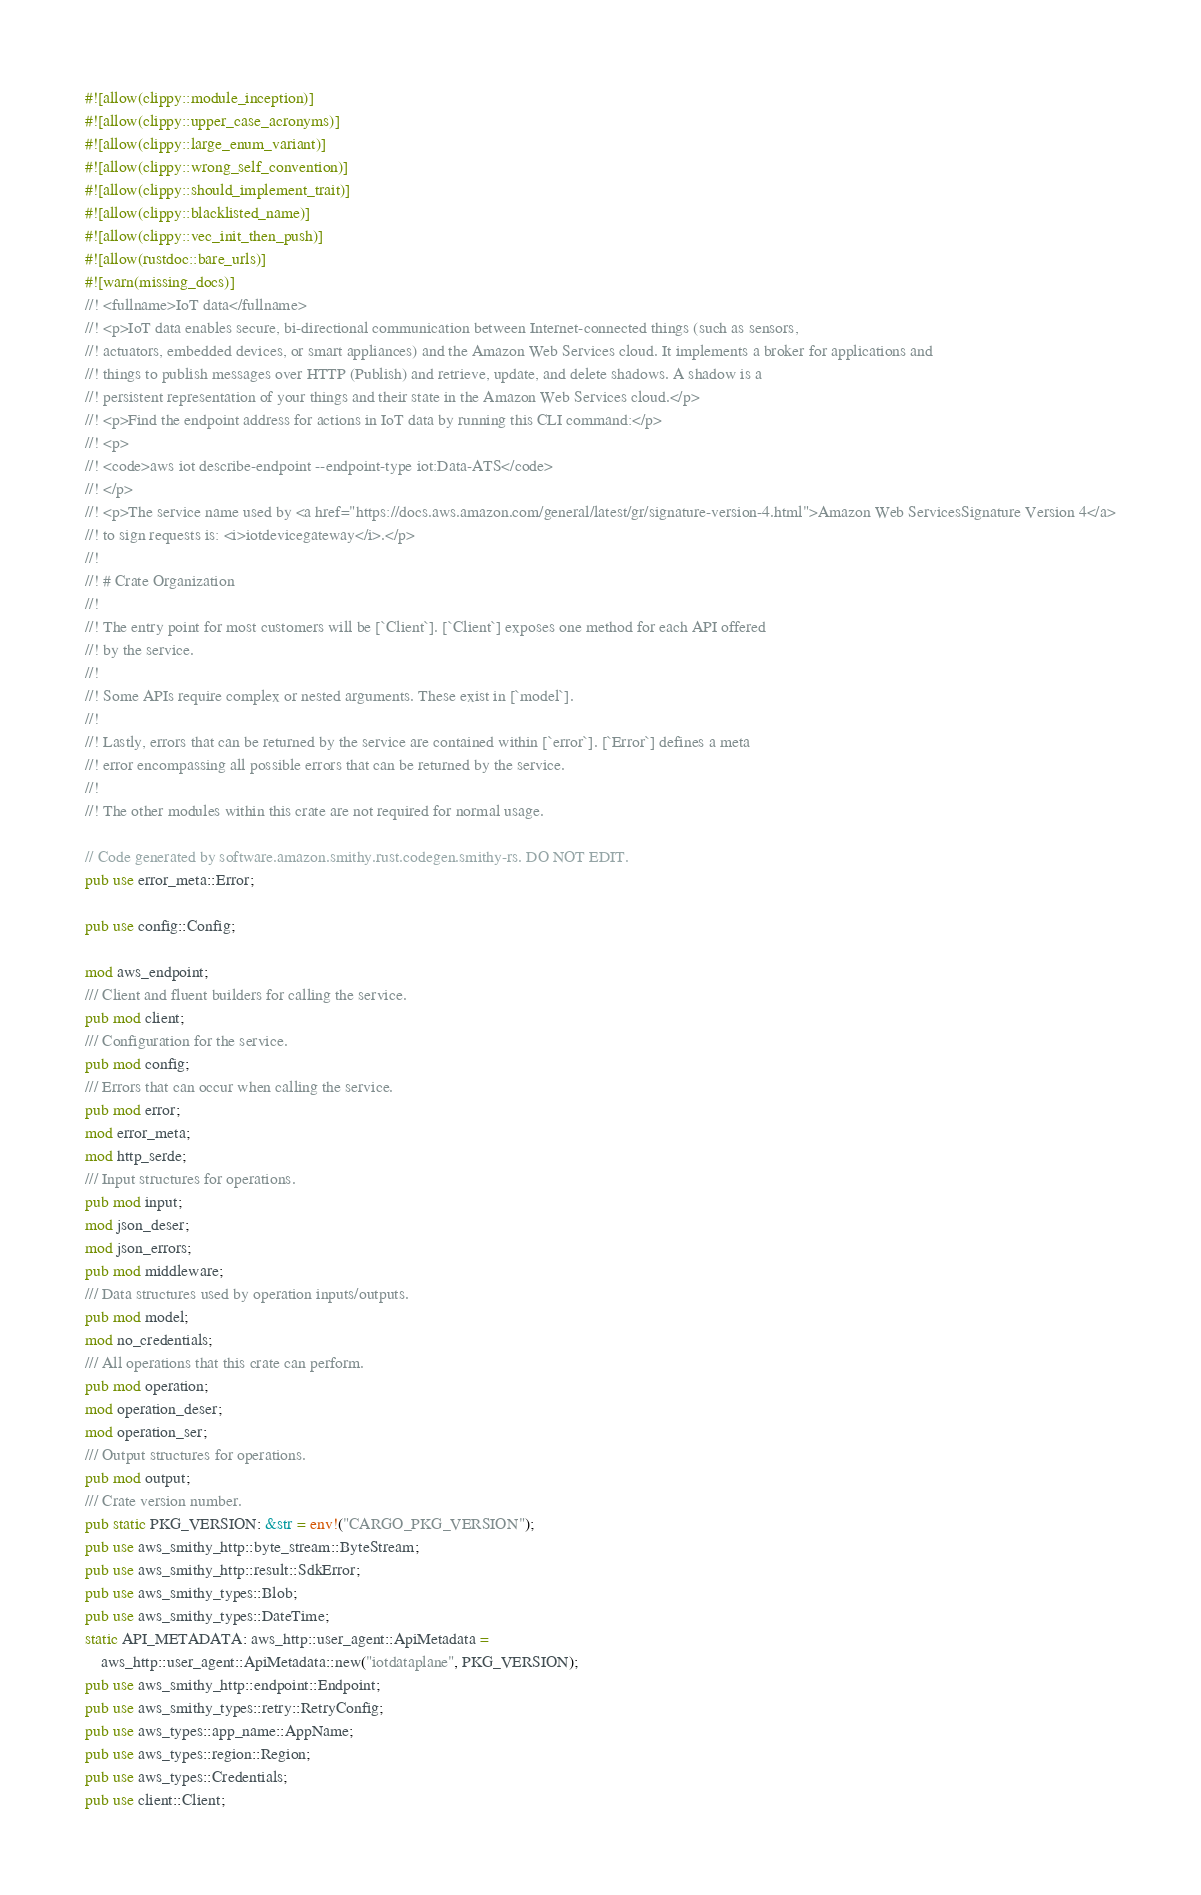Convert code to text. <code><loc_0><loc_0><loc_500><loc_500><_Rust_>#![allow(clippy::module_inception)]
#![allow(clippy::upper_case_acronyms)]
#![allow(clippy::large_enum_variant)]
#![allow(clippy::wrong_self_convention)]
#![allow(clippy::should_implement_trait)]
#![allow(clippy::blacklisted_name)]
#![allow(clippy::vec_init_then_push)]
#![allow(rustdoc::bare_urls)]
#![warn(missing_docs)]
//! <fullname>IoT data</fullname>
//! <p>IoT data enables secure, bi-directional communication between Internet-connected things (such as sensors,
//! actuators, embedded devices, or smart appliances) and the Amazon Web Services cloud. It implements a broker for applications and
//! things to publish messages over HTTP (Publish) and retrieve, update, and delete shadows. A shadow is a
//! persistent representation of your things and their state in the Amazon Web Services cloud.</p>
//! <p>Find the endpoint address for actions in IoT data by running this CLI command:</p>
//! <p>
//! <code>aws iot describe-endpoint --endpoint-type iot:Data-ATS</code>
//! </p>
//! <p>The service name used by <a href="https://docs.aws.amazon.com/general/latest/gr/signature-version-4.html">Amazon Web ServicesSignature Version 4</a>
//! to sign requests is: <i>iotdevicegateway</i>.</p>
//!
//! # Crate Organization
//!
//! The entry point for most customers will be [`Client`]. [`Client`] exposes one method for each API offered
//! by the service.
//!
//! Some APIs require complex or nested arguments. These exist in [`model`].
//!
//! Lastly, errors that can be returned by the service are contained within [`error`]. [`Error`] defines a meta
//! error encompassing all possible errors that can be returned by the service.
//!
//! The other modules within this crate are not required for normal usage.

// Code generated by software.amazon.smithy.rust.codegen.smithy-rs. DO NOT EDIT.
pub use error_meta::Error;

pub use config::Config;

mod aws_endpoint;
/// Client and fluent builders for calling the service.
pub mod client;
/// Configuration for the service.
pub mod config;
/// Errors that can occur when calling the service.
pub mod error;
mod error_meta;
mod http_serde;
/// Input structures for operations.
pub mod input;
mod json_deser;
mod json_errors;
pub mod middleware;
/// Data structures used by operation inputs/outputs.
pub mod model;
mod no_credentials;
/// All operations that this crate can perform.
pub mod operation;
mod operation_deser;
mod operation_ser;
/// Output structures for operations.
pub mod output;
/// Crate version number.
pub static PKG_VERSION: &str = env!("CARGO_PKG_VERSION");
pub use aws_smithy_http::byte_stream::ByteStream;
pub use aws_smithy_http::result::SdkError;
pub use aws_smithy_types::Blob;
pub use aws_smithy_types::DateTime;
static API_METADATA: aws_http::user_agent::ApiMetadata =
    aws_http::user_agent::ApiMetadata::new("iotdataplane", PKG_VERSION);
pub use aws_smithy_http::endpoint::Endpoint;
pub use aws_smithy_types::retry::RetryConfig;
pub use aws_types::app_name::AppName;
pub use aws_types::region::Region;
pub use aws_types::Credentials;
pub use client::Client;
</code> 